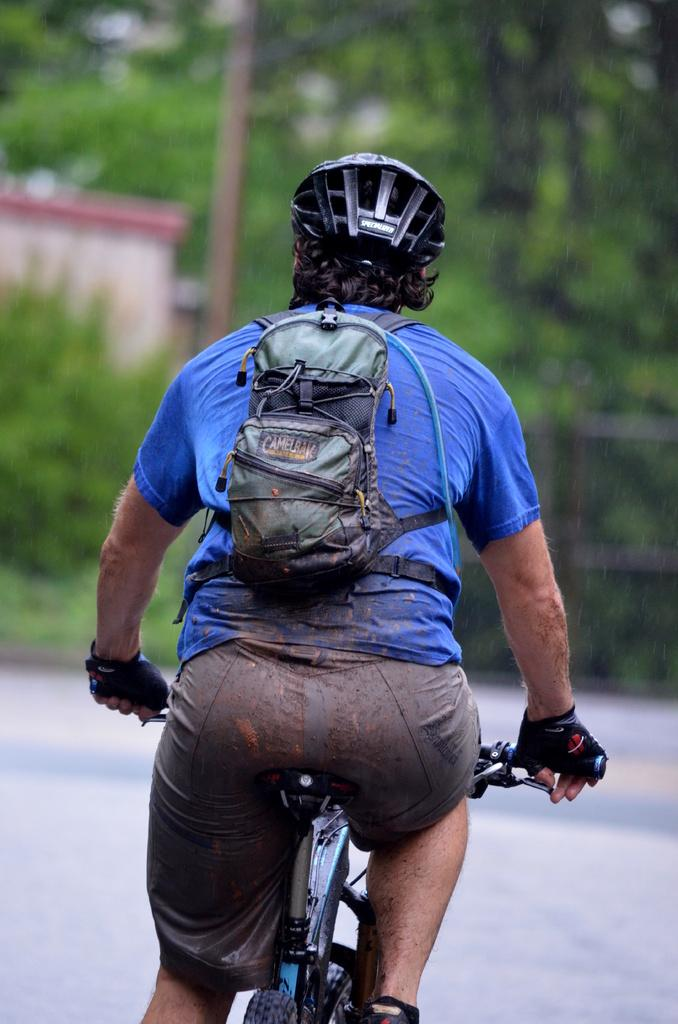What is the person in the image doing? The person is riding a bicycle in the image. What accessories is the person wearing while riding the bicycle? The person is wearing a backpack and a helmet. What can be seen in the background of the image? There is a house, plants, trees, and a pole in the background of the image. What type of force is being applied to the bicycle by the person in the image? There is no information about the force being applied to the bicycle in the image. What kind of doll is sitting on the handlebars of the bicycle? There is no doll present on the handlebars of the bicycle in the image. 